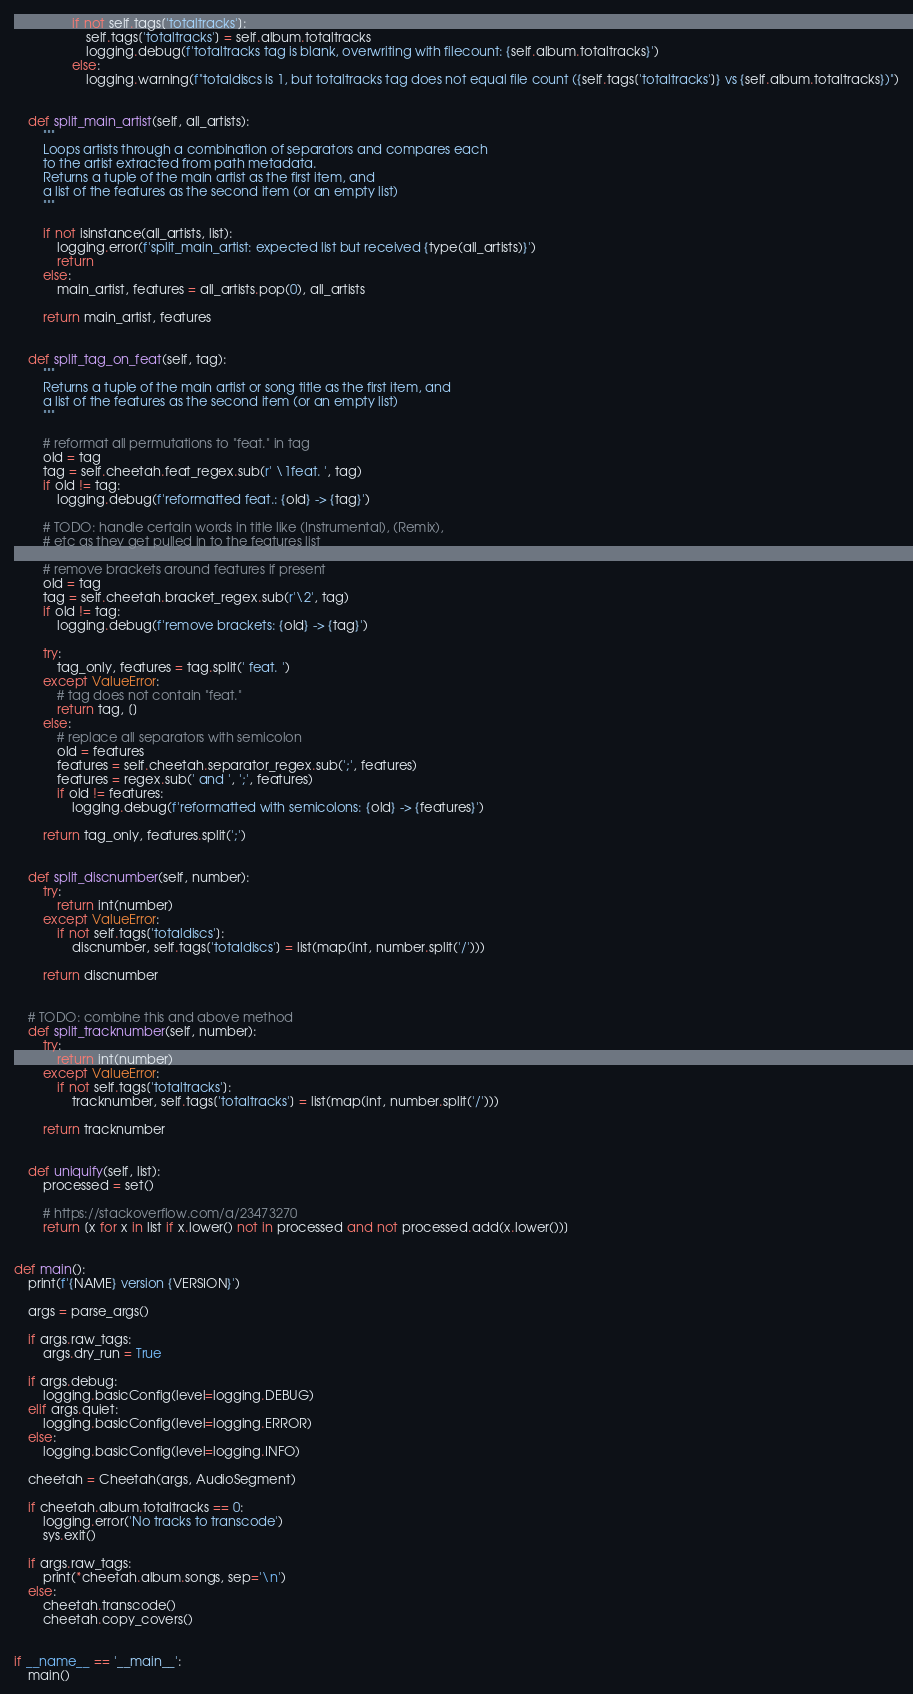Convert code to text. <code><loc_0><loc_0><loc_500><loc_500><_Python_>                if not self.tags['totaltracks']:
                    self.tags['totaltracks'] = self.album.totaltracks
                    logging.debug(f'totaltracks tag is blank, overwriting with filecount: {self.album.totaltracks}')
                else:
                    logging.warning(f"totaldiscs is 1, but totaltracks tag does not equal file count ({self.tags['totaltracks']} vs {self.album.totaltracks})")


    def split_main_artist(self, all_artists):
        """
        Loops artists through a combination of separators and compares each
        to the artist extracted from path metadata.
        Returns a tuple of the main artist as the first item, and
        a list of the features as the second item (or an empty list)
        """

        if not isinstance(all_artists, list):
            logging.error(f'split_main_artist: expected list but received {type(all_artists)}')
            return
        else:
            main_artist, features = all_artists.pop(0), all_artists

        return main_artist, features


    def split_tag_on_feat(self, tag):
        """
        Returns a tuple of the main artist or song title as the first item, and
        a list of the features as the second item (or an empty list)
        """

        # reformat all permutations to "feat." in tag
        old = tag
        tag = self.cheetah.feat_regex.sub(r' \1feat. ', tag)
        if old != tag:
            logging.debug(f'reformatted feat.: {old} -> {tag}')

        # TODO: handle certain words in title like (Instrumental), (Remix),
        # etc as they get pulled in to the features list

        # remove brackets around features if present
        old = tag
        tag = self.cheetah.bracket_regex.sub(r'\2', tag)
        if old != tag:
            logging.debug(f'remove brackets: {old} -> {tag}')

        try:
            tag_only, features = tag.split(' feat. ')
        except ValueError:
            # tag does not contain "feat."
            return tag, []
        else:
            # replace all separators with semicolon
            old = features
            features = self.cheetah.separator_regex.sub(';', features)
            features = regex.sub(' and ', ';', features)
            if old != features:
                logging.debug(f'reformatted with semicolons: {old} -> {features}')

        return tag_only, features.split(';')


    def split_discnumber(self, number):
        try:
            return int(number)
        except ValueError:
            if not self.tags['totaldiscs']:
                discnumber, self.tags['totaldiscs'] = list(map(int, number.split('/')))

        return discnumber


    # TODO: combine this and above method
    def split_tracknumber(self, number):
        try:
            return int(number)
        except ValueError:
            if not self.tags['totaltracks']:
                tracknumber, self.tags['totaltracks'] = list(map(int, number.split('/')))

        return tracknumber


    def uniquify(self, list):
        processed = set()

        # https://stackoverflow.com/a/23473270
        return [x for x in list if x.lower() not in processed and not processed.add(x.lower())]


def main():
    print(f'{NAME} version {VERSION}')

    args = parse_args()

    if args.raw_tags:
        args.dry_run = True

    if args.debug:
        logging.basicConfig(level=logging.DEBUG)
    elif args.quiet:
        logging.basicConfig(level=logging.ERROR)
    else:
        logging.basicConfig(level=logging.INFO)

    cheetah = Cheetah(args, AudioSegment)

    if cheetah.album.totaltracks == 0:
        logging.error('No tracks to transcode')
        sys.exit()

    if args.raw_tags:
        print(*cheetah.album.songs, sep='\n')
    else:
        cheetah.transcode()
        cheetah.copy_covers()


if __name__ == '__main__':
    main()
</code> 